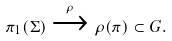Convert formula to latex. <formula><loc_0><loc_0><loc_500><loc_500>\pi _ { 1 } ( \Sigma ) \xrightarrow { \rho } \rho ( \pi ) \subset G .</formula> 